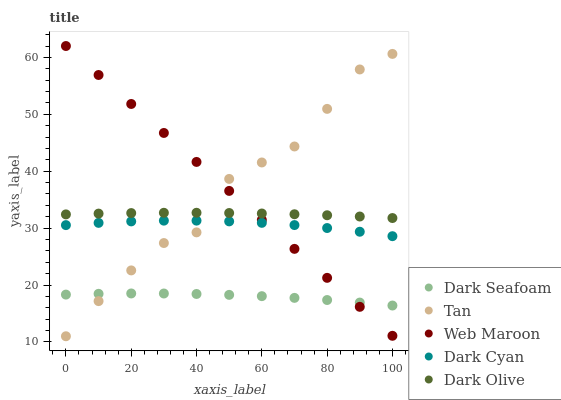Does Dark Seafoam have the minimum area under the curve?
Answer yes or no. Yes. Does Tan have the maximum area under the curve?
Answer yes or no. Yes. Does Dark Olive have the minimum area under the curve?
Answer yes or no. No. Does Dark Olive have the maximum area under the curve?
Answer yes or no. No. Is Web Maroon the smoothest?
Answer yes or no. Yes. Is Tan the roughest?
Answer yes or no. Yes. Is Dark Seafoam the smoothest?
Answer yes or no. No. Is Dark Seafoam the roughest?
Answer yes or no. No. Does Tan have the lowest value?
Answer yes or no. Yes. Does Dark Seafoam have the lowest value?
Answer yes or no. No. Does Web Maroon have the highest value?
Answer yes or no. Yes. Does Dark Olive have the highest value?
Answer yes or no. No. Is Dark Seafoam less than Dark Olive?
Answer yes or no. Yes. Is Dark Olive greater than Dark Cyan?
Answer yes or no. Yes. Does Dark Cyan intersect Tan?
Answer yes or no. Yes. Is Dark Cyan less than Tan?
Answer yes or no. No. Is Dark Cyan greater than Tan?
Answer yes or no. No. Does Dark Seafoam intersect Dark Olive?
Answer yes or no. No. 